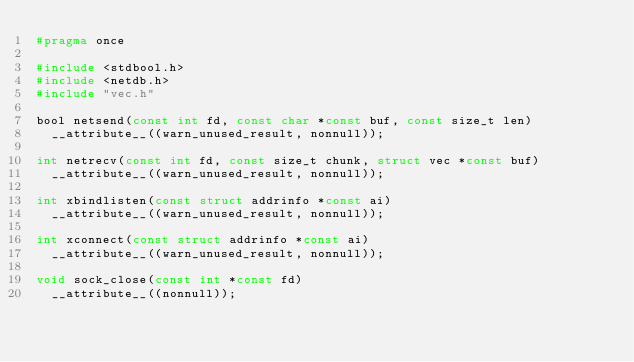<code> <loc_0><loc_0><loc_500><loc_500><_C_>#pragma once

#include <stdbool.h>
#include <netdb.h>
#include "vec.h"

bool netsend(const int fd, const char *const buf, const size_t len)
  __attribute__((warn_unused_result, nonnull));

int netrecv(const int fd, const size_t chunk, struct vec *const buf)
  __attribute__((warn_unused_result, nonnull));

int xbindlisten(const struct addrinfo *const ai)
  __attribute__((warn_unused_result, nonnull));

int xconnect(const struct addrinfo *const ai)
  __attribute__((warn_unused_result, nonnull));

void sock_close(const int *const fd)
  __attribute__((nonnull));
</code> 